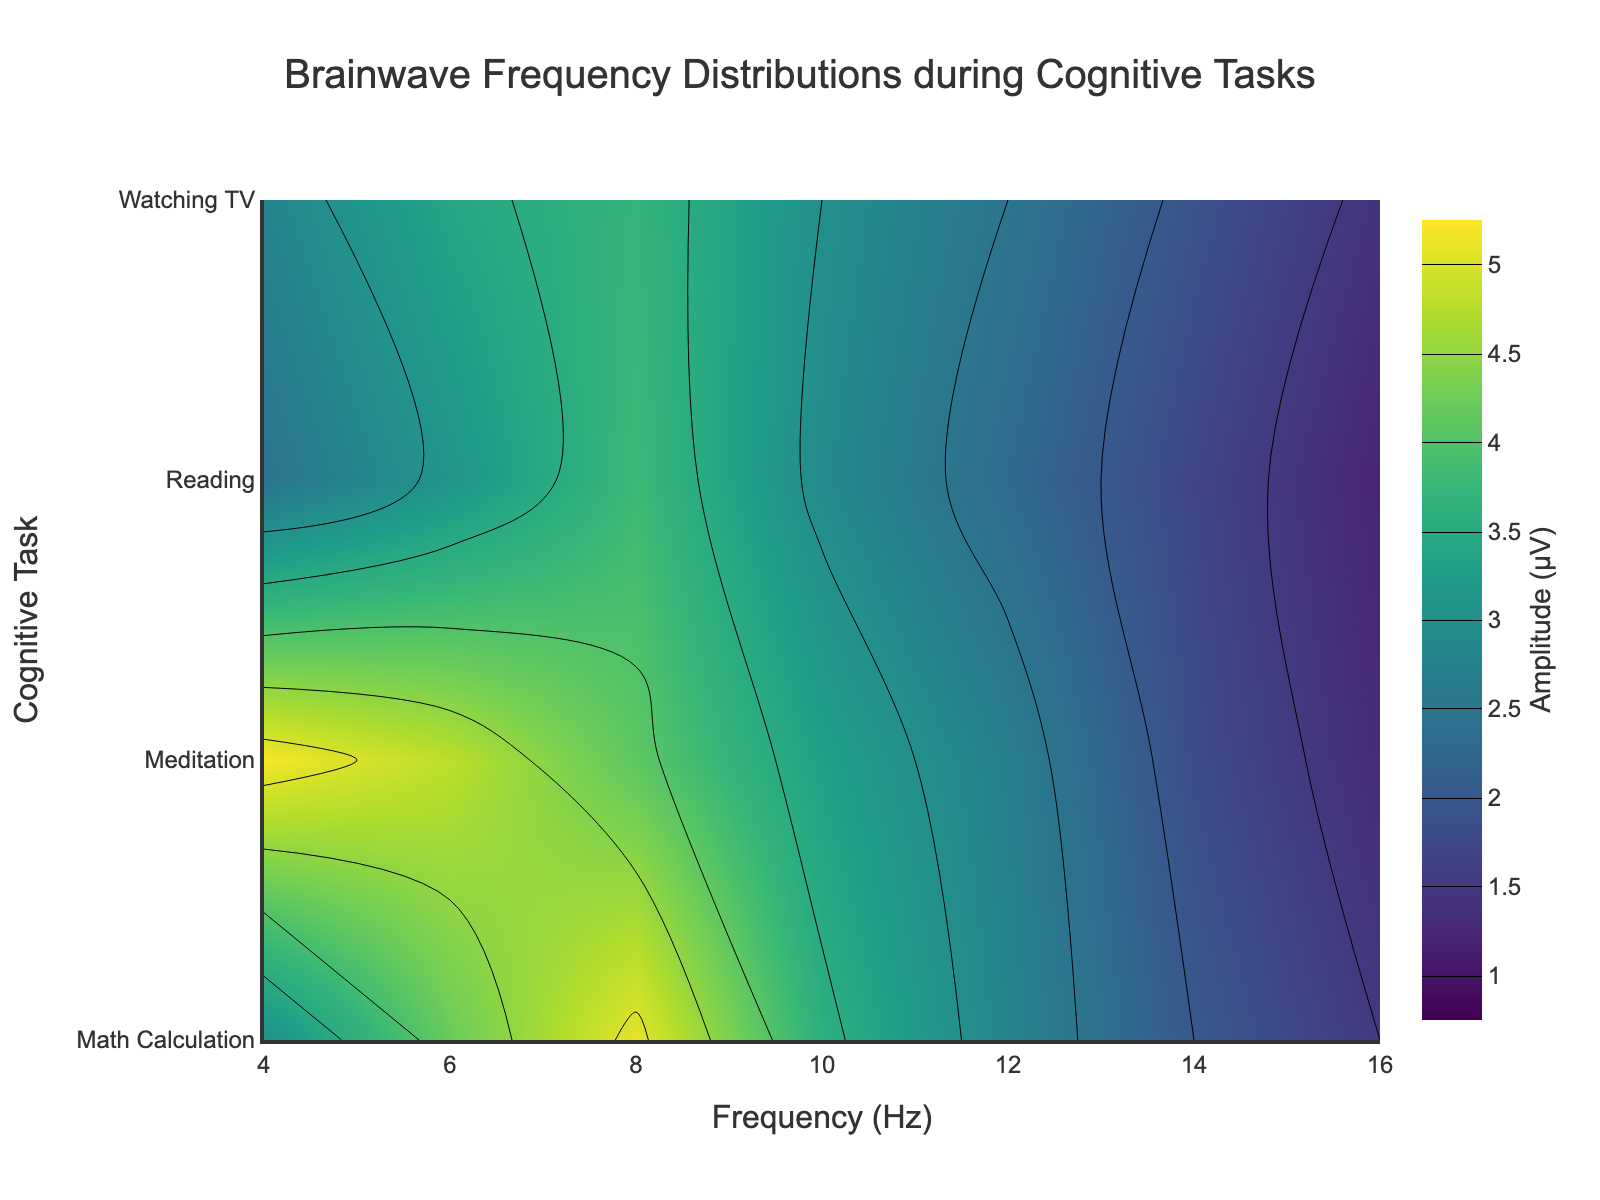What is the highest amplitude observed during the Reading task? Observing the contour plot, the highest amplitude is indicated by the darkest areas in the Reading section. From the data, the peak amplitude is at 8 Hz with an amplitude of 3.8 µV.
Answer: 3.8 µV Which task shows the most pronounced amplitude at 4 Hz? By looking at the darkest region at 4 Hz across the activity tasks, it is clear that the Meditation task shows the highest amplitude. Consulting the data, the amplitude for Meditation is 5.2 µV.
Answer: Meditation At which frequency does the amplitude for Math Calculation exceed that of Reading by more than 1 µV? Cross-referencing the amplitude values for both tasks at each frequency: at 6 Hz (Math Calculation: 4.2, Reading: 3.1) and at 8 Hz (Math Calculation: 5.1, Reading: 3.8), the differences are 1.1 µV and 1.3 µV respectively, both exceeding 1 µV.
Answer: 6 Hz and 8 Hz Compare the amplitudes for Watching TV and Reading at 10 Hz. Which task shows a higher amplitude? Referring to the figure for these tasks at 10 Hz shows Watching TV at 3.0 µV and Reading at 2.9 µV. Thus, Watching TV has a higher amplitude.
Answer: Watching TV What are the two tasks with the lowest amplitude at 16 Hz? By checking the contour plot at 16 Hz, it’s evident that amplitudes decline across all tasks. From the data, Watching TV (1.4 µV) and Meditation (1.3 µV) exhibit the two lowest values.
Answer: Watching TV and Meditation Which cognitive task exhibits the widest range of amplitudes across different frequencies? Observing the color variations (from darkest to lightest) in contour regions, Meditation exhibits the broadest range from 5.2 µV at 4 Hz down to 1.3 µV at 16 Hz.
Answer: Meditation At a frequency of 12 Hz, which task has the closest amplitude to 2.5 µV? Referring to amplitudes at 12 Hz: Reading (2.3 µV), Watching TV (2.5 µV), Math Calculation (2.8 µV), Meditation (2.7 µV), it is evident that Watching TV has an amplitude of exactly 2.5 µV.
Answer: Watching TV How does the amplitude for Math Calculation at 14 Hz compare to the amplitude for Reading at 14 Hz? Consulting the data for these tasks at 14 Hz: Math Calculation (2.0 µV), Reading (1.7 µV), Math Calculation's amplitude is 0.3 µV greater.
Answer: Math Calculation 